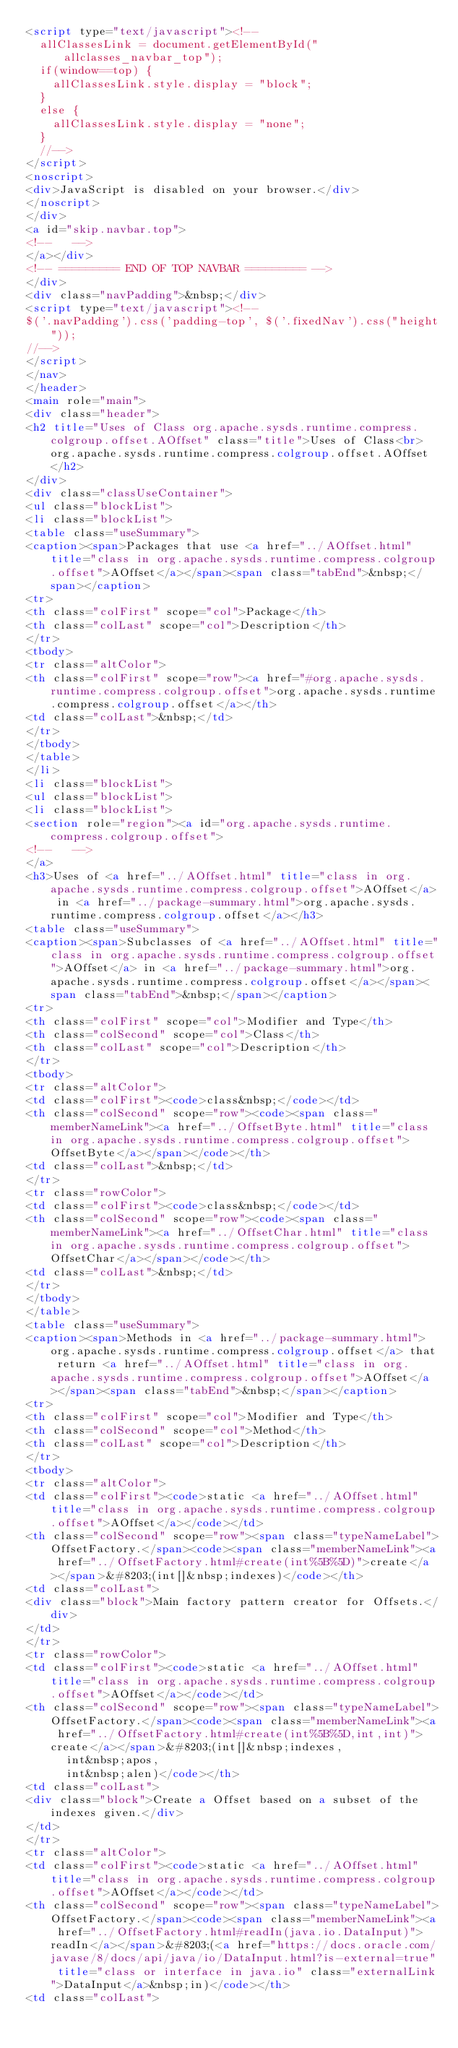Convert code to text. <code><loc_0><loc_0><loc_500><loc_500><_HTML_><script type="text/javascript"><!--
  allClassesLink = document.getElementById("allclasses_navbar_top");
  if(window==top) {
    allClassesLink.style.display = "block";
  }
  else {
    allClassesLink.style.display = "none";
  }
  //-->
</script>
<noscript>
<div>JavaScript is disabled on your browser.</div>
</noscript>
</div>
<a id="skip.navbar.top">
<!--   -->
</a></div>
<!-- ========= END OF TOP NAVBAR ========= -->
</div>
<div class="navPadding">&nbsp;</div>
<script type="text/javascript"><!--
$('.navPadding').css('padding-top', $('.fixedNav').css("height"));
//-->
</script>
</nav>
</header>
<main role="main">
<div class="header">
<h2 title="Uses of Class org.apache.sysds.runtime.compress.colgroup.offset.AOffset" class="title">Uses of Class<br>org.apache.sysds.runtime.compress.colgroup.offset.AOffset</h2>
</div>
<div class="classUseContainer">
<ul class="blockList">
<li class="blockList">
<table class="useSummary">
<caption><span>Packages that use <a href="../AOffset.html" title="class in org.apache.sysds.runtime.compress.colgroup.offset">AOffset</a></span><span class="tabEnd">&nbsp;</span></caption>
<tr>
<th class="colFirst" scope="col">Package</th>
<th class="colLast" scope="col">Description</th>
</tr>
<tbody>
<tr class="altColor">
<th class="colFirst" scope="row"><a href="#org.apache.sysds.runtime.compress.colgroup.offset">org.apache.sysds.runtime.compress.colgroup.offset</a></th>
<td class="colLast">&nbsp;</td>
</tr>
</tbody>
</table>
</li>
<li class="blockList">
<ul class="blockList">
<li class="blockList">
<section role="region"><a id="org.apache.sysds.runtime.compress.colgroup.offset">
<!--   -->
</a>
<h3>Uses of <a href="../AOffset.html" title="class in org.apache.sysds.runtime.compress.colgroup.offset">AOffset</a> in <a href="../package-summary.html">org.apache.sysds.runtime.compress.colgroup.offset</a></h3>
<table class="useSummary">
<caption><span>Subclasses of <a href="../AOffset.html" title="class in org.apache.sysds.runtime.compress.colgroup.offset">AOffset</a> in <a href="../package-summary.html">org.apache.sysds.runtime.compress.colgroup.offset</a></span><span class="tabEnd">&nbsp;</span></caption>
<tr>
<th class="colFirst" scope="col">Modifier and Type</th>
<th class="colSecond" scope="col">Class</th>
<th class="colLast" scope="col">Description</th>
</tr>
<tbody>
<tr class="altColor">
<td class="colFirst"><code>class&nbsp;</code></td>
<th class="colSecond" scope="row"><code><span class="memberNameLink"><a href="../OffsetByte.html" title="class in org.apache.sysds.runtime.compress.colgroup.offset">OffsetByte</a></span></code></th>
<td class="colLast">&nbsp;</td>
</tr>
<tr class="rowColor">
<td class="colFirst"><code>class&nbsp;</code></td>
<th class="colSecond" scope="row"><code><span class="memberNameLink"><a href="../OffsetChar.html" title="class in org.apache.sysds.runtime.compress.colgroup.offset">OffsetChar</a></span></code></th>
<td class="colLast">&nbsp;</td>
</tr>
</tbody>
</table>
<table class="useSummary">
<caption><span>Methods in <a href="../package-summary.html">org.apache.sysds.runtime.compress.colgroup.offset</a> that return <a href="../AOffset.html" title="class in org.apache.sysds.runtime.compress.colgroup.offset">AOffset</a></span><span class="tabEnd">&nbsp;</span></caption>
<tr>
<th class="colFirst" scope="col">Modifier and Type</th>
<th class="colSecond" scope="col">Method</th>
<th class="colLast" scope="col">Description</th>
</tr>
<tbody>
<tr class="altColor">
<td class="colFirst"><code>static <a href="../AOffset.html" title="class in org.apache.sysds.runtime.compress.colgroup.offset">AOffset</a></code></td>
<th class="colSecond" scope="row"><span class="typeNameLabel">OffsetFactory.</span><code><span class="memberNameLink"><a href="../OffsetFactory.html#create(int%5B%5D)">create</a></span>&#8203;(int[]&nbsp;indexes)</code></th>
<td class="colLast">
<div class="block">Main factory pattern creator for Offsets.</div>
</td>
</tr>
<tr class="rowColor">
<td class="colFirst"><code>static <a href="../AOffset.html" title="class in org.apache.sysds.runtime.compress.colgroup.offset">AOffset</a></code></td>
<th class="colSecond" scope="row"><span class="typeNameLabel">OffsetFactory.</span><code><span class="memberNameLink"><a href="../OffsetFactory.html#create(int%5B%5D,int,int)">create</a></span>&#8203;(int[]&nbsp;indexes,
      int&nbsp;apos,
      int&nbsp;alen)</code></th>
<td class="colLast">
<div class="block">Create a Offset based on a subset of the indexes given.</div>
</td>
</tr>
<tr class="altColor">
<td class="colFirst"><code>static <a href="../AOffset.html" title="class in org.apache.sysds.runtime.compress.colgroup.offset">AOffset</a></code></td>
<th class="colSecond" scope="row"><span class="typeNameLabel">OffsetFactory.</span><code><span class="memberNameLink"><a href="../OffsetFactory.html#readIn(java.io.DataInput)">readIn</a></span>&#8203;(<a href="https://docs.oracle.com/javase/8/docs/api/java/io/DataInput.html?is-external=true" title="class or interface in java.io" class="externalLink">DataInput</a>&nbsp;in)</code></th>
<td class="colLast"></code> 